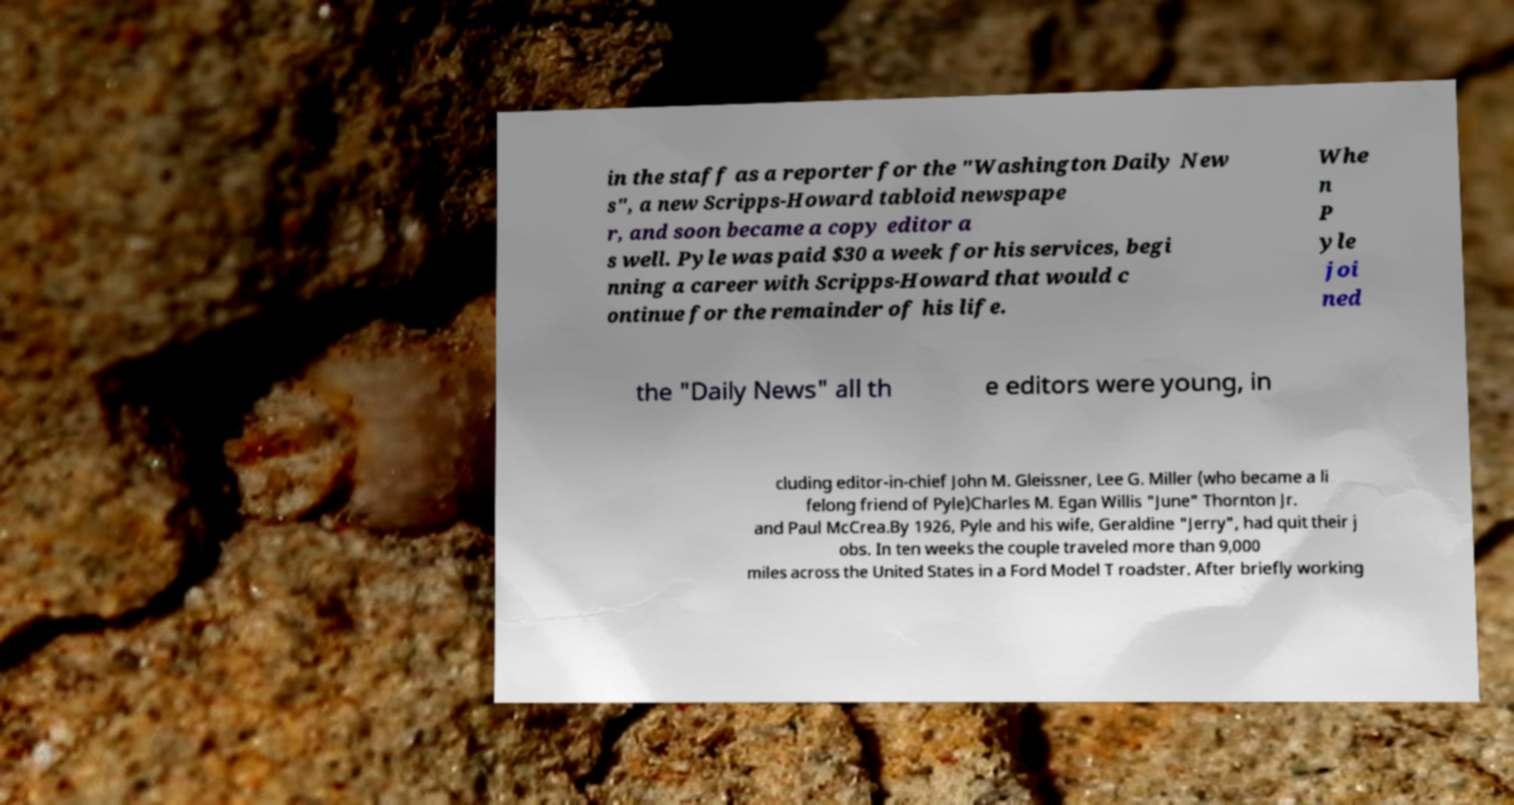I need the written content from this picture converted into text. Can you do that? in the staff as a reporter for the "Washington Daily New s", a new Scripps-Howard tabloid newspape r, and soon became a copy editor a s well. Pyle was paid $30 a week for his services, begi nning a career with Scripps-Howard that would c ontinue for the remainder of his life. Whe n P yle joi ned the "Daily News" all th e editors were young, in cluding editor-in-chief John M. Gleissner, Lee G. Miller (who became a li felong friend of Pyle)Charles M. Egan Willis "June" Thornton Jr. and Paul McCrea.By 1926, Pyle and his wife, Geraldine "Jerry", had quit their j obs. In ten weeks the couple traveled more than 9,000 miles across the United States in a Ford Model T roadster. After briefly working 